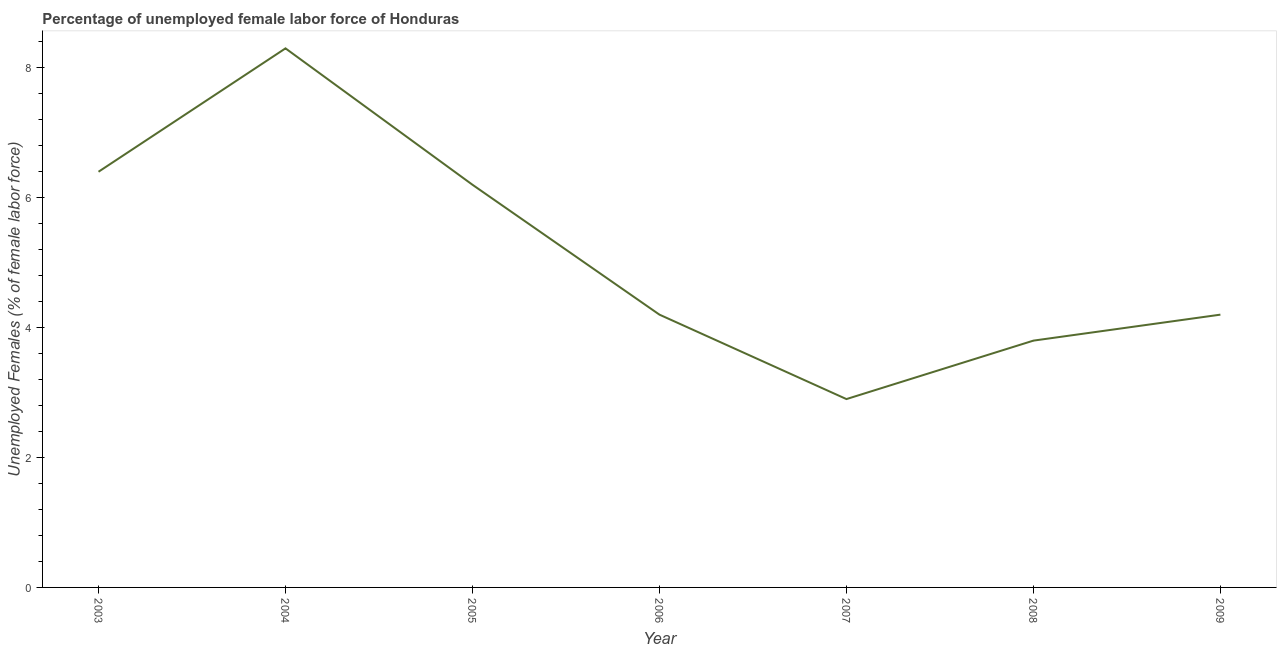What is the total unemployed female labour force in 2008?
Offer a terse response. 3.8. Across all years, what is the maximum total unemployed female labour force?
Give a very brief answer. 8.3. Across all years, what is the minimum total unemployed female labour force?
Provide a succinct answer. 2.9. In which year was the total unemployed female labour force minimum?
Provide a short and direct response. 2007. What is the sum of the total unemployed female labour force?
Offer a terse response. 36. What is the difference between the total unemployed female labour force in 2003 and 2009?
Offer a terse response. 2.2. What is the average total unemployed female labour force per year?
Ensure brevity in your answer.  5.14. What is the median total unemployed female labour force?
Your response must be concise. 4.2. Do a majority of the years between 2004 and 2008 (inclusive) have total unemployed female labour force greater than 3.6 %?
Keep it short and to the point. Yes. What is the ratio of the total unemployed female labour force in 2004 to that in 2006?
Your response must be concise. 1.98. What is the difference between the highest and the second highest total unemployed female labour force?
Your answer should be compact. 1.9. Is the sum of the total unemployed female labour force in 2005 and 2008 greater than the maximum total unemployed female labour force across all years?
Offer a very short reply. Yes. What is the difference between the highest and the lowest total unemployed female labour force?
Offer a terse response. 5.4. In how many years, is the total unemployed female labour force greater than the average total unemployed female labour force taken over all years?
Ensure brevity in your answer.  3. How many years are there in the graph?
Keep it short and to the point. 7. What is the difference between two consecutive major ticks on the Y-axis?
Ensure brevity in your answer.  2. Does the graph contain any zero values?
Offer a very short reply. No. What is the title of the graph?
Give a very brief answer. Percentage of unemployed female labor force of Honduras. What is the label or title of the Y-axis?
Give a very brief answer. Unemployed Females (% of female labor force). What is the Unemployed Females (% of female labor force) of 2003?
Offer a very short reply. 6.4. What is the Unemployed Females (% of female labor force) in 2004?
Ensure brevity in your answer.  8.3. What is the Unemployed Females (% of female labor force) of 2005?
Make the answer very short. 6.2. What is the Unemployed Females (% of female labor force) in 2006?
Offer a terse response. 4.2. What is the Unemployed Females (% of female labor force) of 2007?
Your answer should be compact. 2.9. What is the Unemployed Females (% of female labor force) of 2008?
Your answer should be very brief. 3.8. What is the Unemployed Females (% of female labor force) of 2009?
Ensure brevity in your answer.  4.2. What is the difference between the Unemployed Females (% of female labor force) in 2003 and 2004?
Offer a terse response. -1.9. What is the difference between the Unemployed Females (% of female labor force) in 2003 and 2005?
Your response must be concise. 0.2. What is the difference between the Unemployed Females (% of female labor force) in 2003 and 2007?
Make the answer very short. 3.5. What is the difference between the Unemployed Females (% of female labor force) in 2003 and 2008?
Provide a short and direct response. 2.6. What is the difference between the Unemployed Females (% of female labor force) in 2004 and 2006?
Provide a short and direct response. 4.1. What is the difference between the Unemployed Females (% of female labor force) in 2005 and 2007?
Make the answer very short. 3.3. What is the difference between the Unemployed Females (% of female labor force) in 2007 and 2008?
Provide a short and direct response. -0.9. What is the difference between the Unemployed Females (% of female labor force) in 2008 and 2009?
Make the answer very short. -0.4. What is the ratio of the Unemployed Females (% of female labor force) in 2003 to that in 2004?
Your answer should be compact. 0.77. What is the ratio of the Unemployed Females (% of female labor force) in 2003 to that in 2005?
Make the answer very short. 1.03. What is the ratio of the Unemployed Females (% of female labor force) in 2003 to that in 2006?
Keep it short and to the point. 1.52. What is the ratio of the Unemployed Females (% of female labor force) in 2003 to that in 2007?
Your response must be concise. 2.21. What is the ratio of the Unemployed Females (% of female labor force) in 2003 to that in 2008?
Make the answer very short. 1.68. What is the ratio of the Unemployed Females (% of female labor force) in 2003 to that in 2009?
Your answer should be compact. 1.52. What is the ratio of the Unemployed Females (% of female labor force) in 2004 to that in 2005?
Your response must be concise. 1.34. What is the ratio of the Unemployed Females (% of female labor force) in 2004 to that in 2006?
Make the answer very short. 1.98. What is the ratio of the Unemployed Females (% of female labor force) in 2004 to that in 2007?
Offer a very short reply. 2.86. What is the ratio of the Unemployed Females (% of female labor force) in 2004 to that in 2008?
Your answer should be very brief. 2.18. What is the ratio of the Unemployed Females (% of female labor force) in 2004 to that in 2009?
Make the answer very short. 1.98. What is the ratio of the Unemployed Females (% of female labor force) in 2005 to that in 2006?
Ensure brevity in your answer.  1.48. What is the ratio of the Unemployed Females (% of female labor force) in 2005 to that in 2007?
Offer a very short reply. 2.14. What is the ratio of the Unemployed Females (% of female labor force) in 2005 to that in 2008?
Make the answer very short. 1.63. What is the ratio of the Unemployed Females (% of female labor force) in 2005 to that in 2009?
Ensure brevity in your answer.  1.48. What is the ratio of the Unemployed Females (% of female labor force) in 2006 to that in 2007?
Your response must be concise. 1.45. What is the ratio of the Unemployed Females (% of female labor force) in 2006 to that in 2008?
Ensure brevity in your answer.  1.1. What is the ratio of the Unemployed Females (% of female labor force) in 2007 to that in 2008?
Give a very brief answer. 0.76. What is the ratio of the Unemployed Females (% of female labor force) in 2007 to that in 2009?
Your response must be concise. 0.69. What is the ratio of the Unemployed Females (% of female labor force) in 2008 to that in 2009?
Make the answer very short. 0.91. 